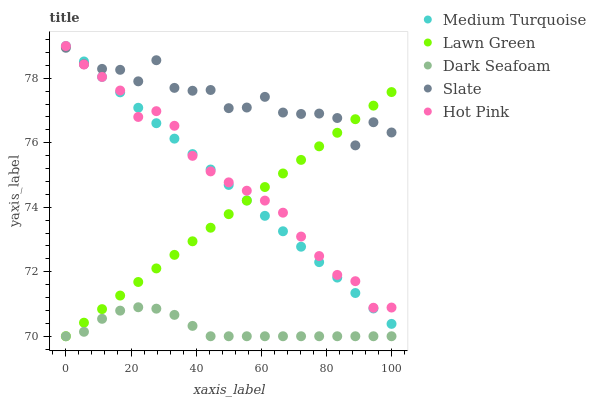Does Dark Seafoam have the minimum area under the curve?
Answer yes or no. Yes. Does Slate have the maximum area under the curve?
Answer yes or no. Yes. Does Hot Pink have the minimum area under the curve?
Answer yes or no. No. Does Hot Pink have the maximum area under the curve?
Answer yes or no. No. Is Medium Turquoise the smoothest?
Answer yes or no. Yes. Is Slate the roughest?
Answer yes or no. Yes. Is Dark Seafoam the smoothest?
Answer yes or no. No. Is Dark Seafoam the roughest?
Answer yes or no. No. Does Lawn Green have the lowest value?
Answer yes or no. Yes. Does Hot Pink have the lowest value?
Answer yes or no. No. Does Medium Turquoise have the highest value?
Answer yes or no. Yes. Does Dark Seafoam have the highest value?
Answer yes or no. No. Is Dark Seafoam less than Hot Pink?
Answer yes or no. Yes. Is Medium Turquoise greater than Dark Seafoam?
Answer yes or no. Yes. Does Slate intersect Hot Pink?
Answer yes or no. Yes. Is Slate less than Hot Pink?
Answer yes or no. No. Is Slate greater than Hot Pink?
Answer yes or no. No. Does Dark Seafoam intersect Hot Pink?
Answer yes or no. No. 